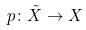<formula> <loc_0><loc_0><loc_500><loc_500>p \colon \tilde { X } \rightarrow X</formula> 